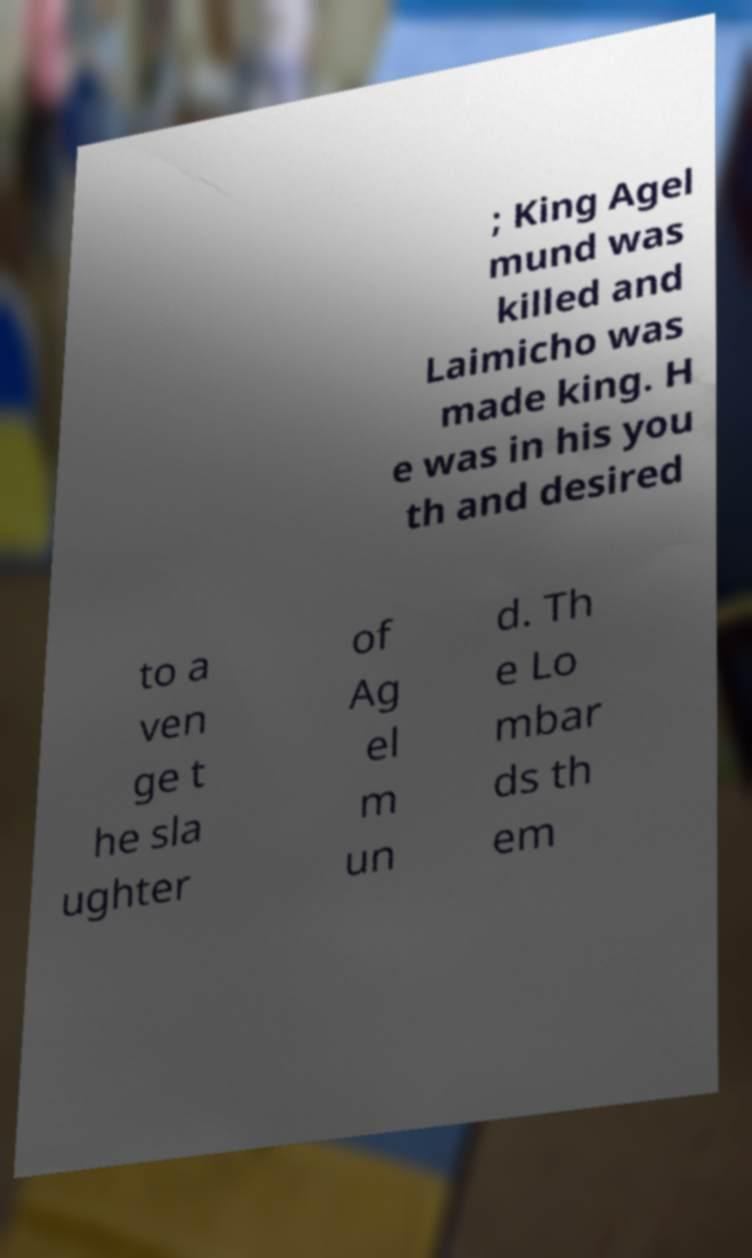There's text embedded in this image that I need extracted. Can you transcribe it verbatim? ; King Agel mund was killed and Laimicho was made king. H e was in his you th and desired to a ven ge t he sla ughter of Ag el m un d. Th e Lo mbar ds th em 